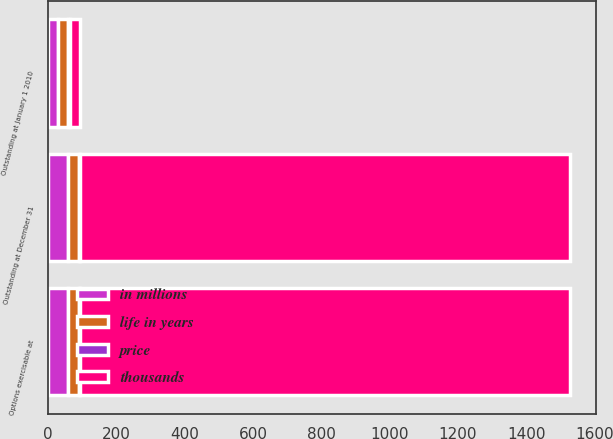Convert chart to OTSL. <chart><loc_0><loc_0><loc_500><loc_500><stacked_bar_chart><ecel><fcel>Outstanding at January 1 2010<fcel>Outstanding at December 31<fcel>Options exercisable at<nl><fcel>thousands<fcel>30.65<fcel>1436<fcel>1436<nl><fcel>life in years<fcel>27.98<fcel>30.65<fcel>30.65<nl><fcel>price<fcel>5.8<fcel>3.4<fcel>3.4<nl><fcel>in millions<fcel>29.7<fcel>58.8<fcel>58.8<nl></chart> 